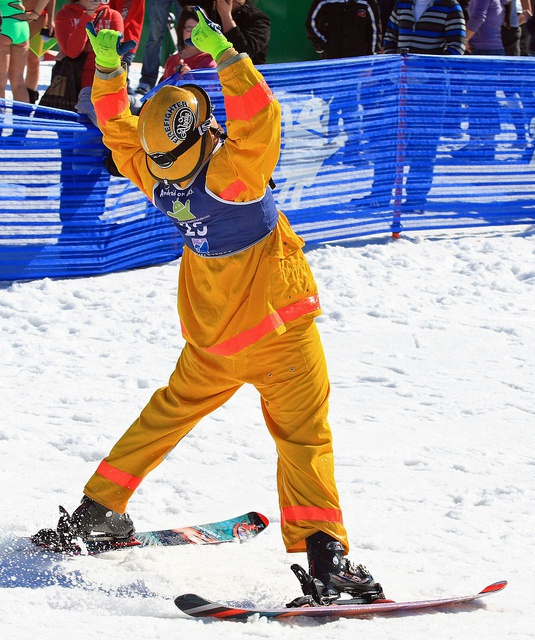Describe the objects in this image and their specific colors. I can see people in lightgreen, red, orange, and black tones, people in lightgreen, blue, darkblue, black, and navy tones, people in lightgreen, black, blue, darkblue, and lightblue tones, skis in lightgreen, lightgray, darkgray, black, and gray tones, and people in lightgreen, maroon, black, and salmon tones in this image. 